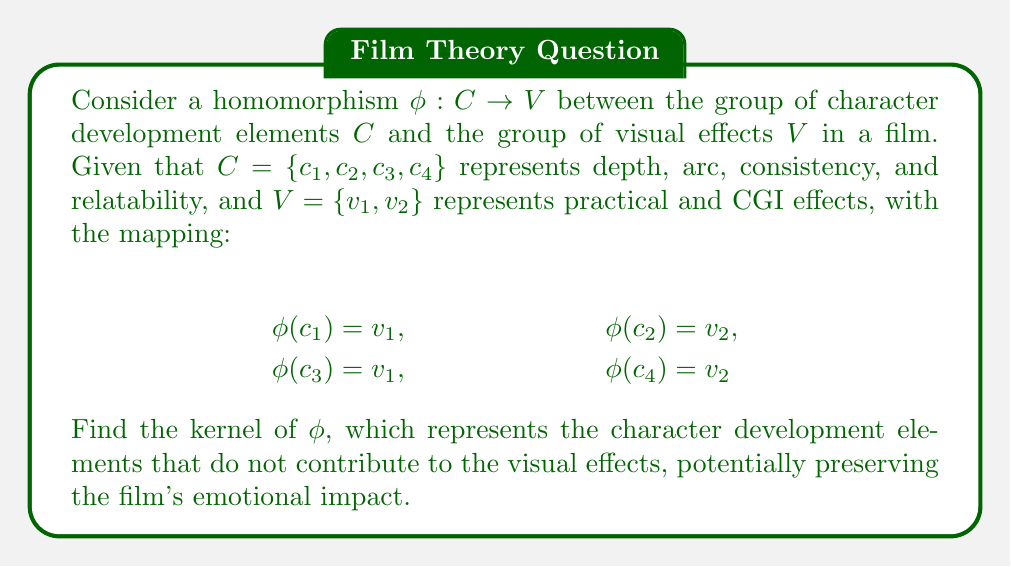What is the answer to this math problem? To find the kernel of the homomorphism $\phi$, we need to determine which elements of $C$ map to the identity element in $V$. However, since we're not given an explicit identity element in $V$, we'll consider both $v_1$ and $v_2$ as potential identity elements:

1. If $v_1$ is the identity:
   $\phi(c_1) = v_1$ and $\phi(c_3) = v_1$
   $\ker(\phi) = \{c_1, c_3\}$

2. If $v_2$ is the identity:
   $\phi(c_2) = v_2$ and $\phi(c_4) = v_2$
   $\ker(\phi) = \{c_2, c_4\}$

3. If neither $v_1$ nor $v_2$ is the identity:
   $\ker(\phi) = \{\}$ (empty set)

In the context of the film critic's perspective, the kernel represents character development elements that don't contribute to visual effects, potentially preserving emotional impact. The largest possible kernel would be preferable in this case.
Answer: $\ker(\phi) = \{c_1, c_3\}$ or $\{c_2, c_4\}$, depending on which element in $V$ is the identity. 